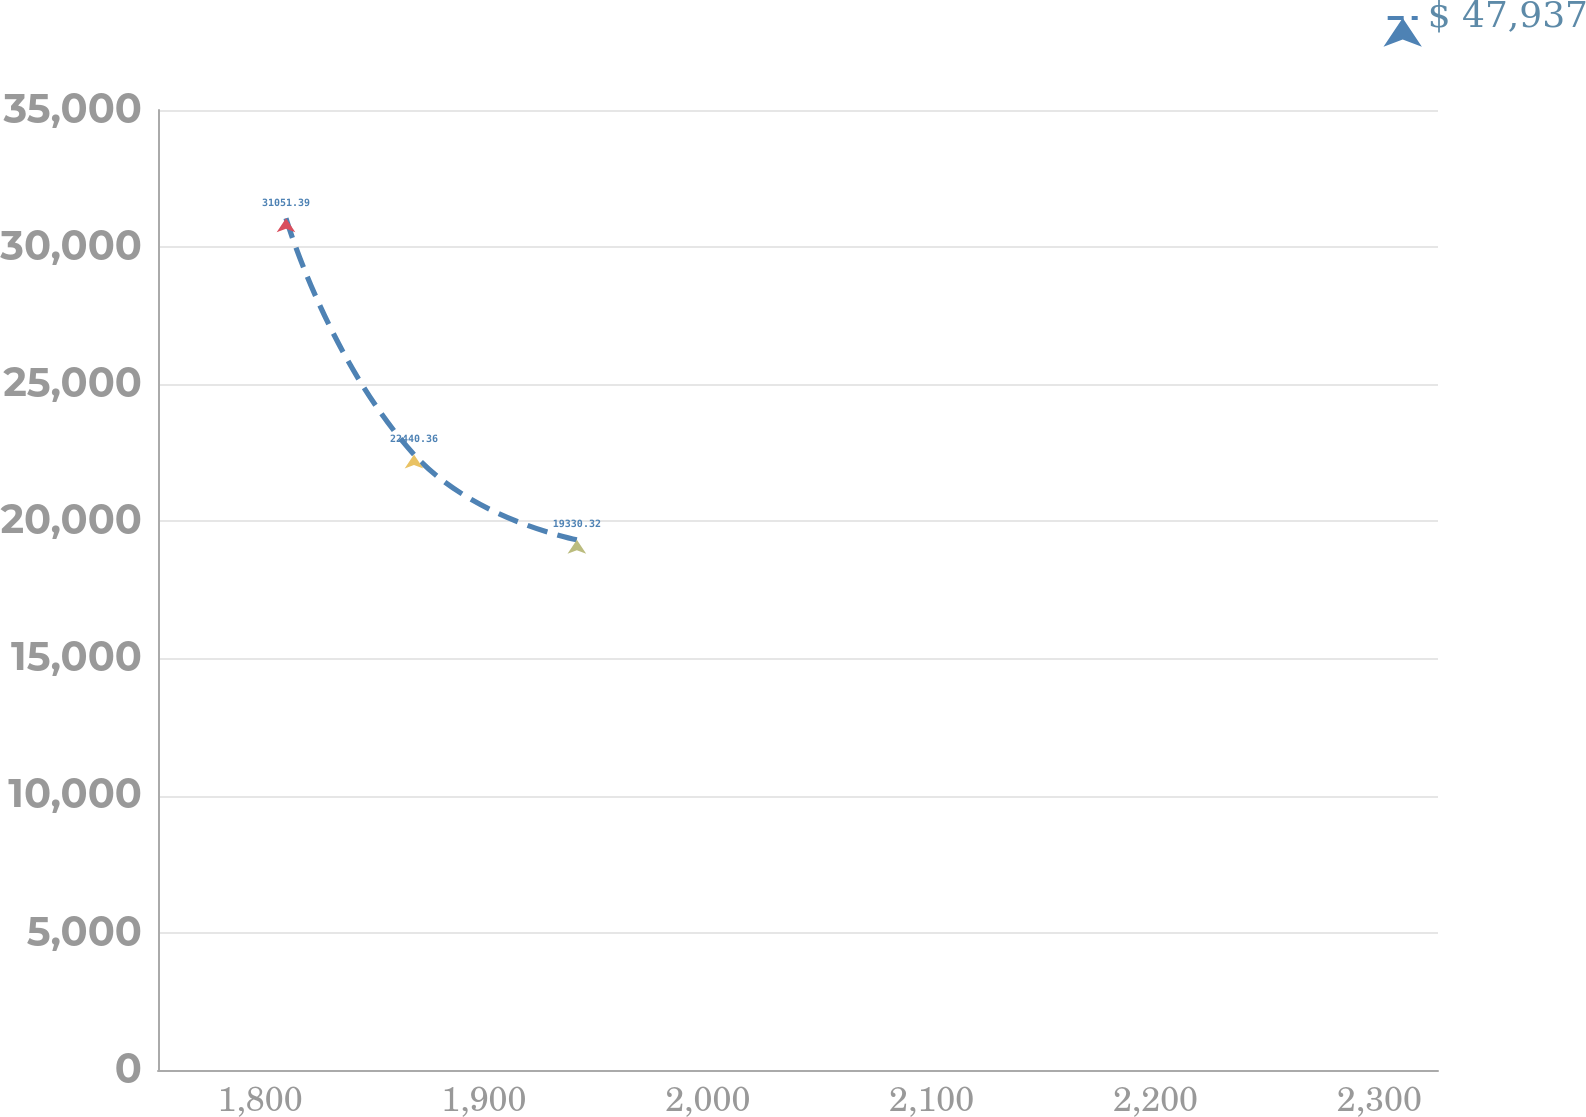Convert chart to OTSL. <chart><loc_0><loc_0><loc_500><loc_500><line_chart><ecel><fcel>$ 47,937<nl><fcel>1811.6<fcel>31051.4<nl><fcel>1868.78<fcel>22440.4<nl><fcel>1941.53<fcel>19330.3<nl><fcel>2383.39<fcel>13105.3<nl></chart> 